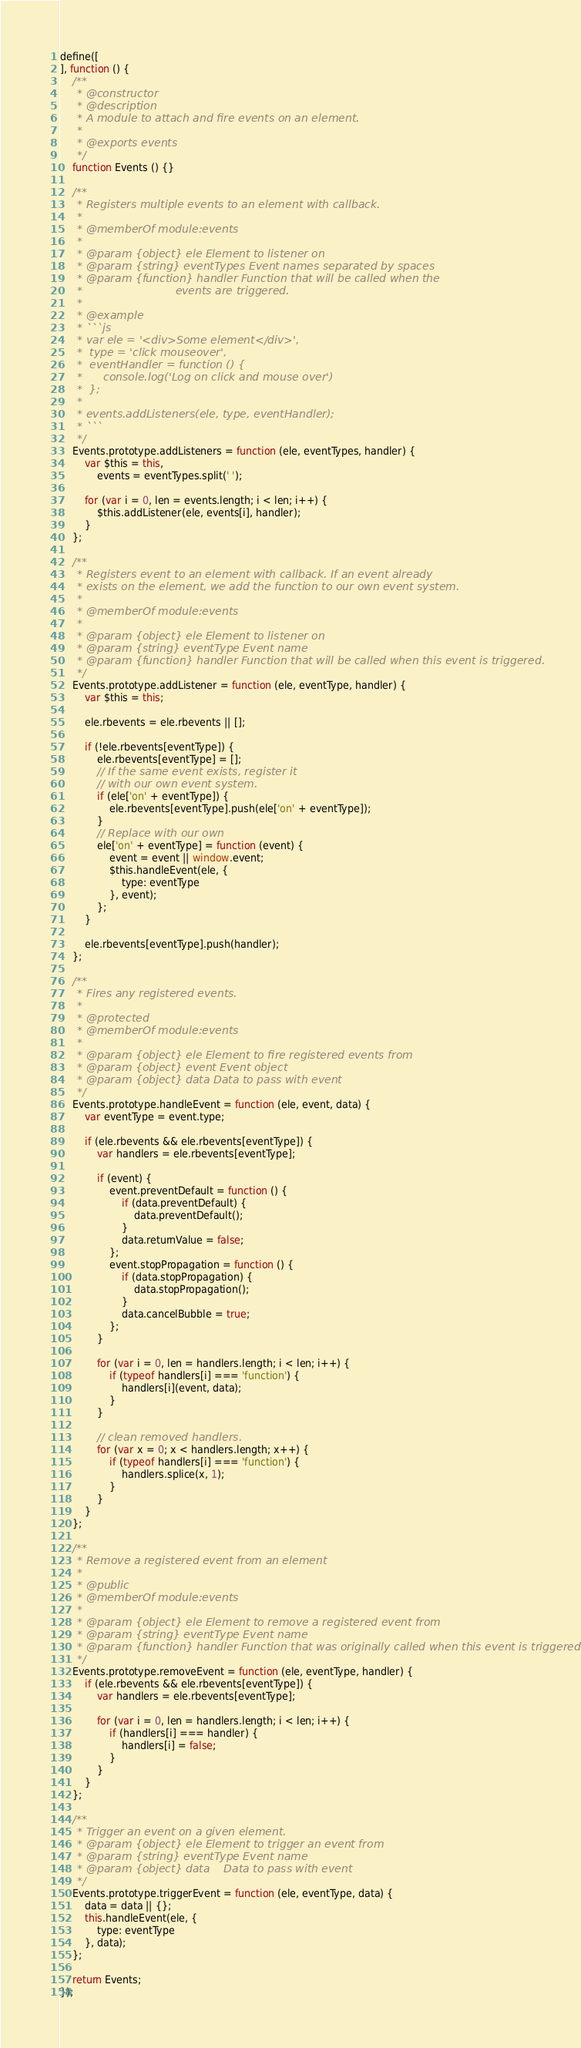Convert code to text. <code><loc_0><loc_0><loc_500><loc_500><_JavaScript_>define([
], function () {
    /**
     * @constructor
     * @description
     * A module to attach and fire events on an element.
     *
     * @exports events
     */
    function Events () {}

    /**
     * Registers multiple events to an element with callback.
     *
     * @memberOf module:events
     *
     * @param {object} ele Element to listener on
     * @param {string} eventTypes Event names separated by spaces
     * @param {function} handler Function that will be called when the
     *                           events are triggered.
     *
     * @example
     * ```js
     * var ele = '<div>Some element</div>',
     * 	type = 'click mouseover',
     * 	eventHandler = function () {
     * 		console.log('Log on click and mouse over')
     * 	};
     *
     * events.addListeners(ele, type, eventHandler);
     * ```
     */
    Events.prototype.addListeners = function (ele, eventTypes, handler) {
        var $this = this,
            events = eventTypes.split(' ');

        for (var i = 0, len = events.length; i < len; i++) {
            $this.addListener(ele, events[i], handler);
        }
    };

    /**
     * Registers event to an element with callback. If an event already
     * exists on the element, we add the function to our own event system.
     *
     * @memberOf module:events
     *
     * @param {object} ele Element to listener on
     * @param {string} eventType Event name
     * @param {function} handler Function that will be called when this event is triggered.
     */
    Events.prototype.addListener = function (ele, eventType, handler) {
        var $this = this;

        ele.rbevents = ele.rbevents || [];

        if (!ele.rbevents[eventType]) {
            ele.rbevents[eventType] = [];
            // If the same event exists, register it
            // with our own event system.
            if (ele['on' + eventType]) {
                ele.rbevents[eventType].push(ele['on' + eventType]);
            }
            // Replace with our own
            ele['on' + eventType] = function (event) {
                event = event || window.event;
                $this.handleEvent(ele, {
                    type: eventType
                }, event);
            };
        }

        ele.rbevents[eventType].push(handler);
    };

    /**
     * Fires any registered events.
     *
     * @protected
     * @memberOf module:events
     *
     * @param {object} ele Element to fire registered events from
     * @param {object} event Event object
     * @param {object} data Data to pass with event
     */
    Events.prototype.handleEvent = function (ele, event, data) {
        var eventType = event.type;

        if (ele.rbevents && ele.rbevents[eventType]) {
            var handlers = ele.rbevents[eventType];

            if (event) {
                event.preventDefault = function () {
                    if (data.preventDefault) {
                        data.preventDefault();
                    }
                    data.returnValue = false;
                };
                event.stopPropagation = function () {
                    if (data.stopPropagation) {
                        data.stopPropagation();
                    }
                    data.cancelBubble = true;
                };
            }

            for (var i = 0, len = handlers.length; i < len; i++) {
                if (typeof handlers[i] === 'function') {
                    handlers[i](event, data);
                }
            }

            // clean removed handlers.
            for (var x = 0; x < handlers.length; x++) {
                if (typeof handlers[i] === 'function') {
                    handlers.splice(x, 1);
                }
            }
        }
    };

    /**
     * Remove a registered event from an element
     *
     * @public
     * @memberOf module:events
     *
     * @param {object} ele Element to remove a registered event from
     * @param {string} eventType Event name
     * @param {function} handler Function that was originally called when this event is triggered.
     */
    Events.prototype.removeEvent = function (ele, eventType, handler) {
        if (ele.rbevents && ele.rbevents[eventType]) {
            var handlers = ele.rbevents[eventType];

            for (var i = 0, len = handlers.length; i < len; i++) {
                if (handlers[i] === handler) {
                    handlers[i] = false;
                }
            }
        }
    };

    /**
     * Trigger an event on a given element.
     * @param {object} ele Element to trigger an event from
     * @param {string} eventType Event name
     * @param {object} data    Data to pass with event
     */
    Events.prototype.triggerEvent = function (ele, eventType, data) {
        data = data || {};
        this.handleEvent(ele, {
            type: eventType
        }, data);
    };

    return Events;
});
</code> 